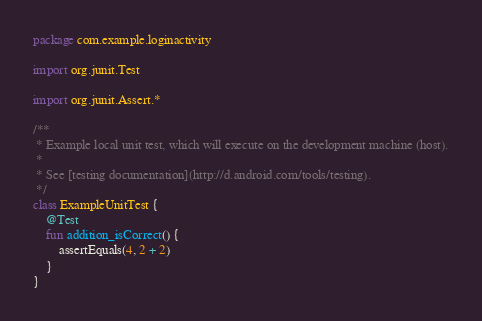Convert code to text. <code><loc_0><loc_0><loc_500><loc_500><_Kotlin_>package com.example.loginactivity

import org.junit.Test

import org.junit.Assert.*

/**
 * Example local unit test, which will execute on the development machine (host).
 *
 * See [testing documentation](http://d.android.com/tools/testing).
 */
class ExampleUnitTest {
    @Test
    fun addition_isCorrect() {
        assertEquals(4, 2 + 2)
    }
}
</code> 